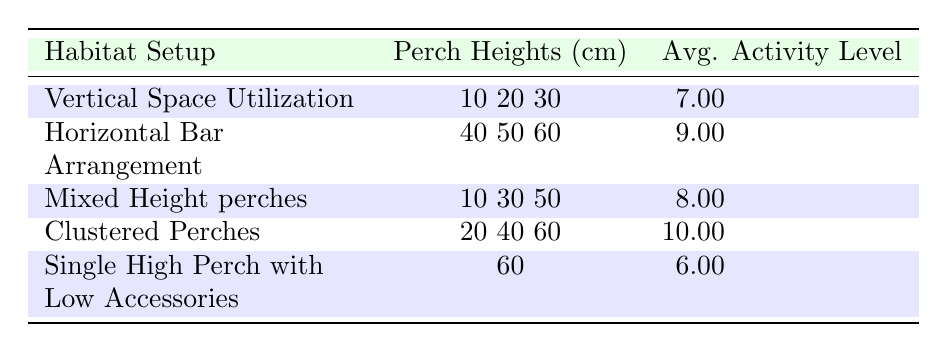What is the average activity level for the "Clustered Perches" habitat setup? The table shows that the average activity level for "Clustered Perches" is listed as 10.0.
Answer: 10.0 Which habitat setup has the highest average activity level? By reviewing the average activity levels in the table, "Clustered Perches" has the highest average activity level at 10.0.
Answer: Clustered Perches How many perch heights are used in the "Mixed Height perches" setup? The table indicates that "Mixed Height perches" use perch heights of 10 cm, 30 cm, and 50 cm, totaling three distinct heights.
Answer: 3 Is the average activity level for "Single High Perch with Low Accessories" higher than that for "Vertical Space Utilization"? The average activity level for "Single High Perch with Low Accessories" is 6.0, and for "Vertical Space Utilization" it is 7.0. Since 6.0 is less than 7.0, the statement is false.
Answer: No What is the difference in average activity levels between "Horizontal Bar Arrangement" and "Vertical Space Utilization"? The average activity level for "Horizontal Bar Arrangement" is 9.0, while for "Vertical Space Utilization," it is 7.0. Therefore, the difference is 9.0 - 7.0 = 2.0.
Answer: 2.0 What is the average of the perch heights used in the "Horizontal Bar Arrangement"? The perch heights for "Horizontal Bar Arrangement" are 40 cm, 50 cm, and 60 cm. The average is calculated as (40 + 50 + 60) / 3 = 50.0 cm.
Answer: 50.0 Which bird showed the maximum activity level at a perch height of 50 cm? From the bird activity levels, the African Grey shows the highest activity level at 50 cm with a level of 11.
Answer: African Grey Are all habitat setups utilizing perch heights above 30 cm having higher activity levels than setups using lower heights? The "Vertical Space Utilization" setup, which uses heights below 30 cm, has an average activity level of 7.0 while setups using heights above 30 cm, like "Horizontal Bar Arrangement" with 9.0, confirm that this statement is false.
Answer: No 